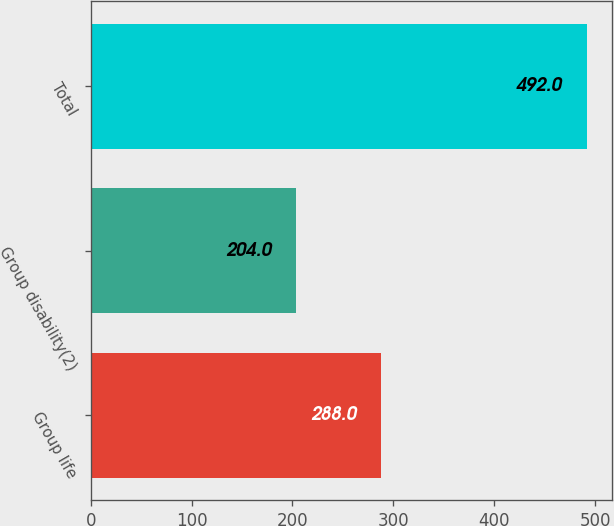Convert chart to OTSL. <chart><loc_0><loc_0><loc_500><loc_500><bar_chart><fcel>Group life<fcel>Group disability(2)<fcel>Total<nl><fcel>288<fcel>204<fcel>492<nl></chart> 